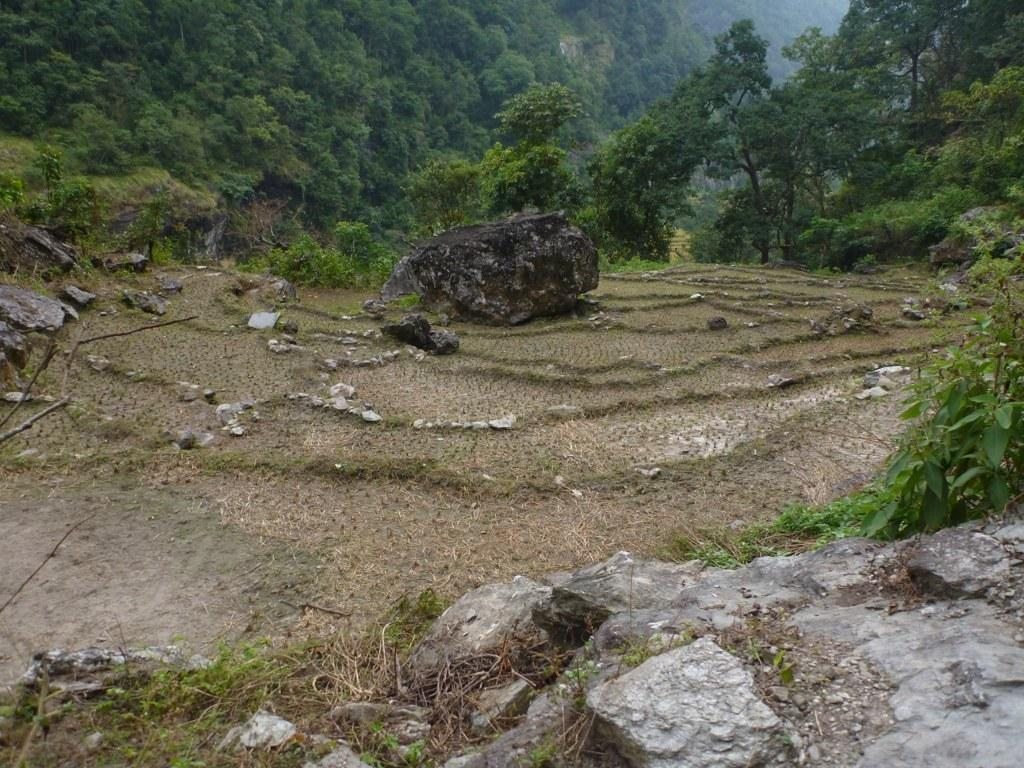What type of landscape is depicted in the image? There is a field in the image. What can be found within the field? There are rocks in the field. What can be seen in the distance in the image? There are trees in the background of the image. What committee is meeting in the field in the image? There is no committee meeting in the field in the image; it is a field with rocks and trees in the background. 